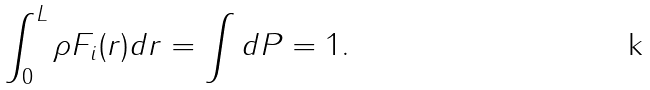Convert formula to latex. <formula><loc_0><loc_0><loc_500><loc_500>\int _ { 0 } ^ { L } \rho F _ { i } ( r ) d r = \int d P = 1 .</formula> 